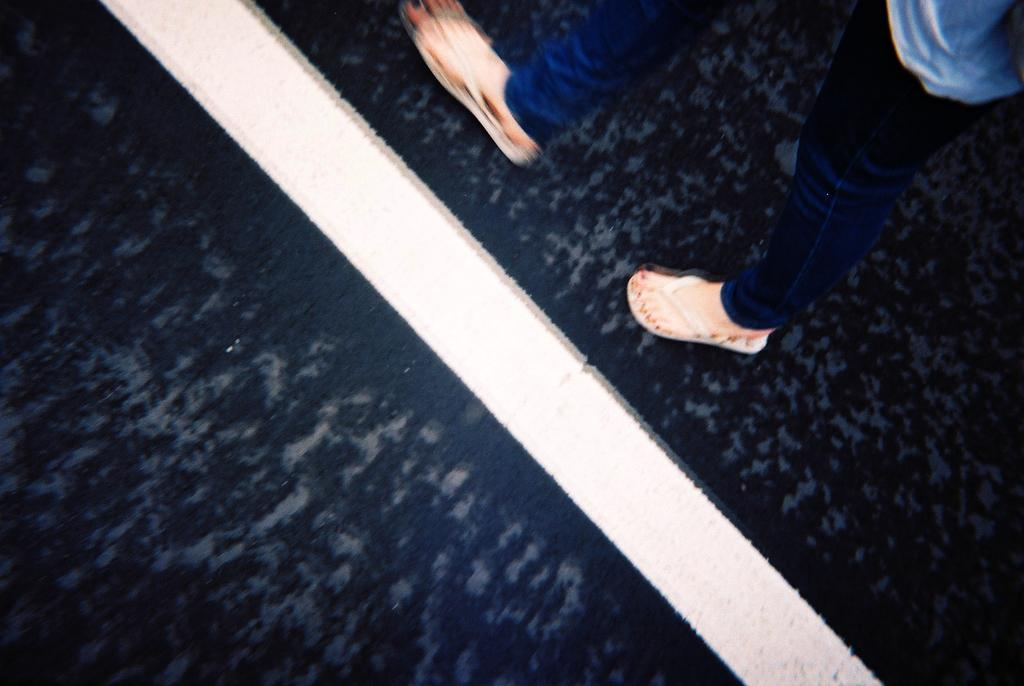Who or what is present in the image? There is a person in the image. Can you describe the position of the person in the image? The person is on the floor. What is the tendency of the cakes in the image? There are no cakes present in the image, so it is not possible to determine their tendency. 